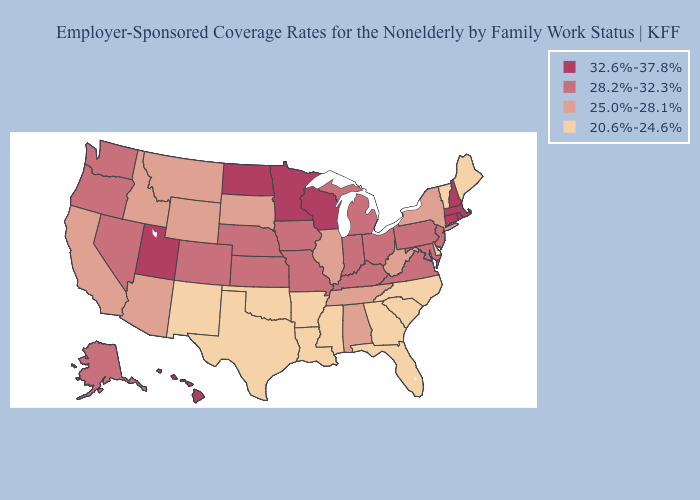Which states have the lowest value in the USA?
Give a very brief answer. Arkansas, Delaware, Florida, Georgia, Louisiana, Maine, Mississippi, New Mexico, North Carolina, Oklahoma, South Carolina, Texas, Vermont. Name the states that have a value in the range 20.6%-24.6%?
Keep it brief. Arkansas, Delaware, Florida, Georgia, Louisiana, Maine, Mississippi, New Mexico, North Carolina, Oklahoma, South Carolina, Texas, Vermont. What is the lowest value in the Northeast?
Short answer required. 20.6%-24.6%. What is the value of Utah?
Be succinct. 32.6%-37.8%. Does Texas have a lower value than Indiana?
Give a very brief answer. Yes. Name the states that have a value in the range 32.6%-37.8%?
Give a very brief answer. Connecticut, Hawaii, Massachusetts, Minnesota, New Hampshire, North Dakota, Rhode Island, Utah, Wisconsin. Which states have the lowest value in the MidWest?
Give a very brief answer. Illinois, South Dakota. Among the states that border Utah , does New Mexico have the lowest value?
Be succinct. Yes. Does Maine have the lowest value in the Northeast?
Short answer required. Yes. Name the states that have a value in the range 20.6%-24.6%?
Write a very short answer. Arkansas, Delaware, Florida, Georgia, Louisiana, Maine, Mississippi, New Mexico, North Carolina, Oklahoma, South Carolina, Texas, Vermont. Name the states that have a value in the range 20.6%-24.6%?
Answer briefly. Arkansas, Delaware, Florida, Georgia, Louisiana, Maine, Mississippi, New Mexico, North Carolina, Oklahoma, South Carolina, Texas, Vermont. What is the highest value in the USA?
Concise answer only. 32.6%-37.8%. What is the lowest value in the West?
Write a very short answer. 20.6%-24.6%. What is the highest value in the USA?
Concise answer only. 32.6%-37.8%. 